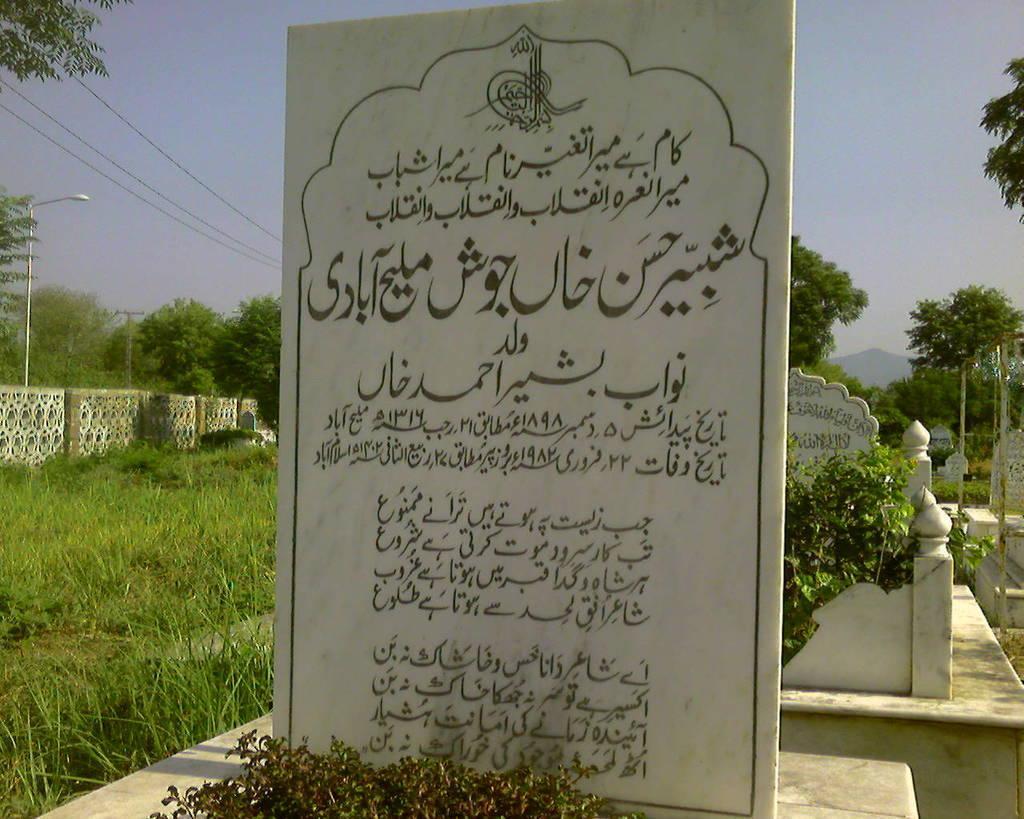In one or two sentences, can you explain what this image depicts? In this picture I can see there is a gravestone and there is something written on it. On to left there is grass, a wall and trees and plants. The sky is clear. 